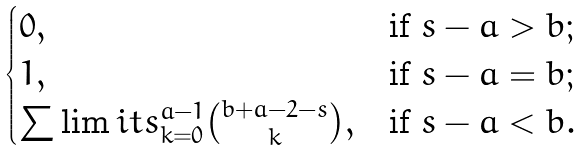Convert formula to latex. <formula><loc_0><loc_0><loc_500><loc_500>\begin{cases} 0 , & \text {if $s-a>b$} ; \\ 1 , & \text {if $s-a=b$} ; \\ \sum \lim i t s _ { k = 0 } ^ { a - 1 } { { b + a - 2 - s } \choose { k } } , & \text {if $s-a<b$} . \end{cases}</formula> 